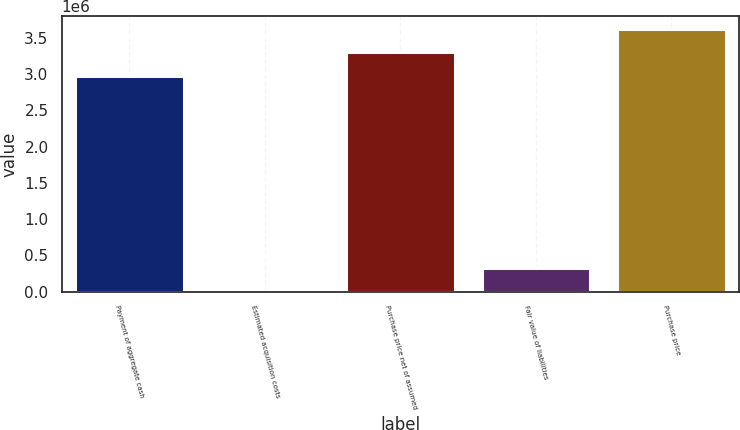Convert chart. <chart><loc_0><loc_0><loc_500><loc_500><bar_chart><fcel>Payment of aggregate cash<fcel>Estimated acquisition costs<fcel>Purchase price net of assumed<fcel>Fair value of liabilities<fcel>Purchase price<nl><fcel>2.97891e+06<fcel>3778<fcel>3.29867e+06<fcel>323535<fcel>3.61842e+06<nl></chart> 